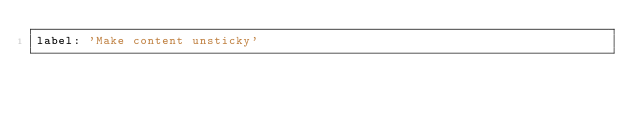Convert code to text. <code><loc_0><loc_0><loc_500><loc_500><_YAML_>label: 'Make content unsticky'
</code> 